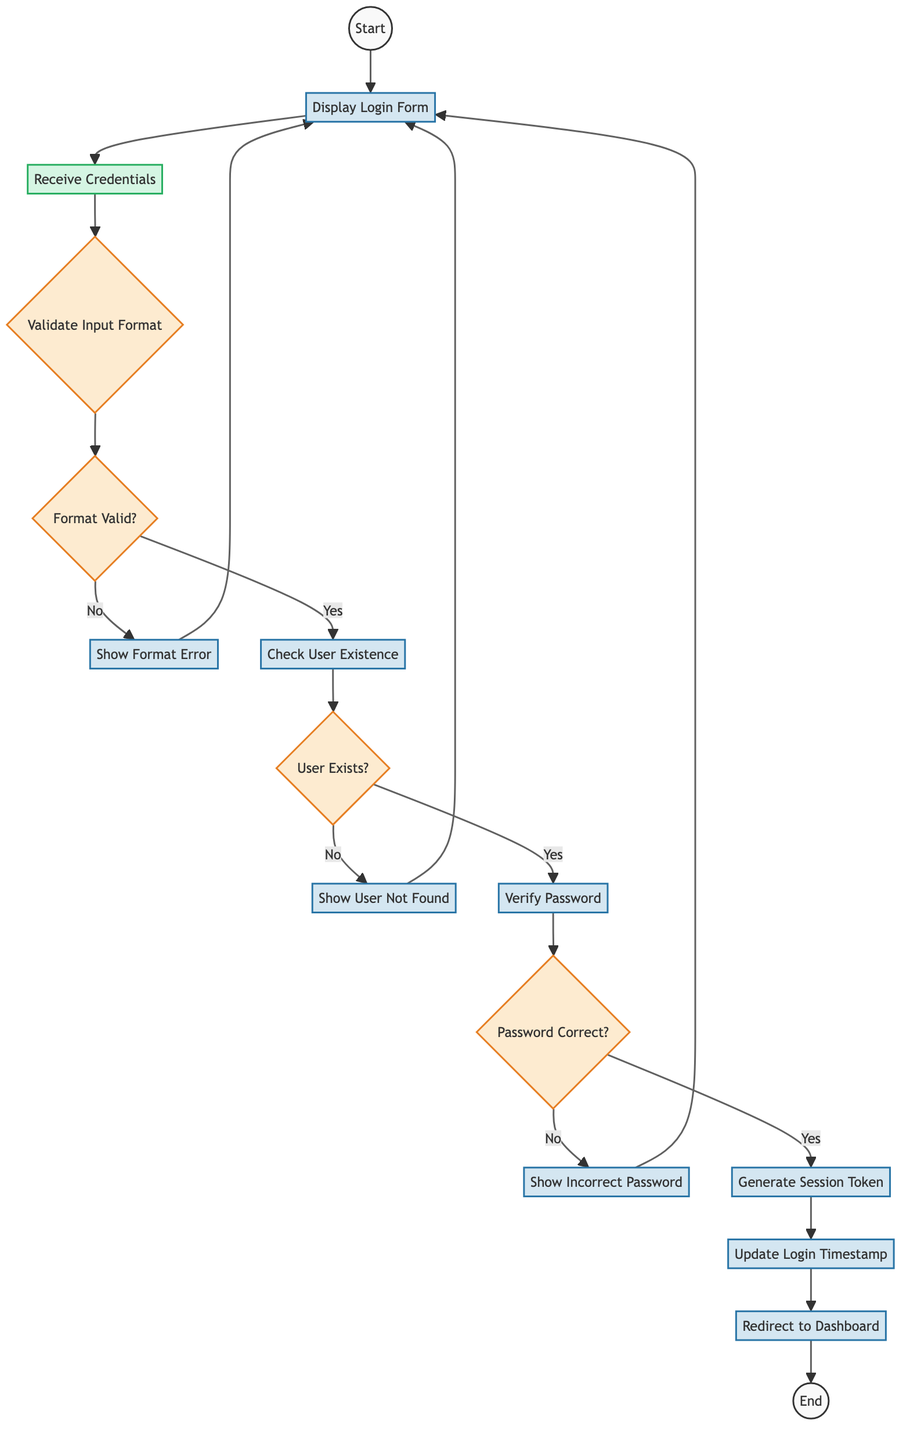What's the first step in the user authentication process? The first step is represented by the "Start" node, indicating the initiation of the authentication process.
Answer: Start How many decision nodes are present in the diagram? The diagram contains four decision nodes: "Validate Input Format," "Format Valid?," "User Exists?," and "Password Correct?" This totals four decision nodes.
Answer: 4 What do you do if the format is invalid? If the format is invalid, the flow goes to the "Show Format Error" process, which indicates an error message will be displayed to the user.
Answer: Show Format Error What happens when the entered username is not found? If the entered username is not found, the flow proceeds to "Show User Not Found," indicating an error message is displayed to the user.
Answer: Show User Not Found What is generated after verifying the password? The next step after verifying the password is generating a session token for the authenticated user.
Answer: Generate Session Token Describe the relationship between "Verify Password" and "User Exists?" nodes. The "Verify Password" node is reached only if the "User Exists?" decision node concludes that the user does exist; it connects directly after the "Yes" outcome from "User Exists?"
Answer: Verify Password What does the final step of the process represent? The final step, represented by the "End" node, signifies the conclusion of the user authentication process, indicating that no further action is required.
Answer: End What action is taken when the password is correct? When the password is correct, the process moves to generate a session token, which is essential for authenticated user sessions.
Answer: Generate Session Token Which node follows "Update Login Timestamp"? Following "Update Login Timestamp," the next step is "Redirect to Dashboard," where the authenticated user is sent to their dashboard.
Answer: Redirect to Dashboard 